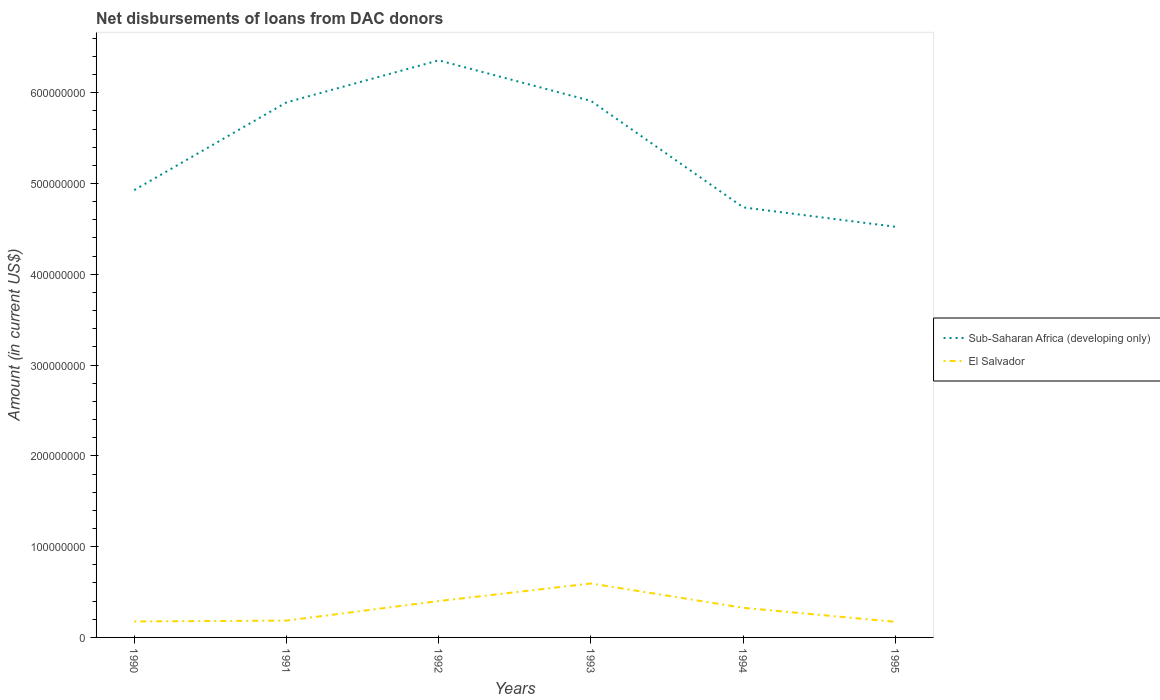How many different coloured lines are there?
Keep it short and to the point. 2. Across all years, what is the maximum amount of loans disbursed in Sub-Saharan Africa (developing only)?
Ensure brevity in your answer.  4.52e+08. In which year was the amount of loans disbursed in El Salvador maximum?
Your answer should be very brief. 1995. What is the total amount of loans disbursed in Sub-Saharan Africa (developing only) in the graph?
Give a very brief answer. -1.43e+08. What is the difference between the highest and the second highest amount of loans disbursed in Sub-Saharan Africa (developing only)?
Give a very brief answer. 1.83e+08. Is the amount of loans disbursed in El Salvador strictly greater than the amount of loans disbursed in Sub-Saharan Africa (developing only) over the years?
Make the answer very short. Yes. How many lines are there?
Provide a succinct answer. 2. How many years are there in the graph?
Your answer should be compact. 6. Are the values on the major ticks of Y-axis written in scientific E-notation?
Keep it short and to the point. No. Does the graph contain grids?
Keep it short and to the point. No. Where does the legend appear in the graph?
Make the answer very short. Center right. How many legend labels are there?
Offer a very short reply. 2. How are the legend labels stacked?
Provide a short and direct response. Vertical. What is the title of the graph?
Offer a terse response. Net disbursements of loans from DAC donors. Does "Indonesia" appear as one of the legend labels in the graph?
Your answer should be very brief. No. What is the label or title of the X-axis?
Give a very brief answer. Years. What is the Amount (in current US$) of Sub-Saharan Africa (developing only) in 1990?
Provide a short and direct response. 4.93e+08. What is the Amount (in current US$) of El Salvador in 1990?
Give a very brief answer. 1.76e+07. What is the Amount (in current US$) of Sub-Saharan Africa (developing only) in 1991?
Your answer should be very brief. 5.89e+08. What is the Amount (in current US$) of El Salvador in 1991?
Give a very brief answer. 1.85e+07. What is the Amount (in current US$) of Sub-Saharan Africa (developing only) in 1992?
Keep it short and to the point. 6.36e+08. What is the Amount (in current US$) in El Salvador in 1992?
Your response must be concise. 4.01e+07. What is the Amount (in current US$) of Sub-Saharan Africa (developing only) in 1993?
Offer a very short reply. 5.91e+08. What is the Amount (in current US$) of El Salvador in 1993?
Keep it short and to the point. 5.94e+07. What is the Amount (in current US$) in Sub-Saharan Africa (developing only) in 1994?
Make the answer very short. 4.74e+08. What is the Amount (in current US$) of El Salvador in 1994?
Offer a very short reply. 3.26e+07. What is the Amount (in current US$) in Sub-Saharan Africa (developing only) in 1995?
Your response must be concise. 4.52e+08. What is the Amount (in current US$) in El Salvador in 1995?
Provide a short and direct response. 1.72e+07. Across all years, what is the maximum Amount (in current US$) of Sub-Saharan Africa (developing only)?
Ensure brevity in your answer.  6.36e+08. Across all years, what is the maximum Amount (in current US$) in El Salvador?
Offer a very short reply. 5.94e+07. Across all years, what is the minimum Amount (in current US$) in Sub-Saharan Africa (developing only)?
Your answer should be very brief. 4.52e+08. Across all years, what is the minimum Amount (in current US$) of El Salvador?
Provide a succinct answer. 1.72e+07. What is the total Amount (in current US$) of Sub-Saharan Africa (developing only) in the graph?
Ensure brevity in your answer.  3.23e+09. What is the total Amount (in current US$) of El Salvador in the graph?
Give a very brief answer. 1.85e+08. What is the difference between the Amount (in current US$) in Sub-Saharan Africa (developing only) in 1990 and that in 1991?
Offer a terse response. -9.66e+07. What is the difference between the Amount (in current US$) of El Salvador in 1990 and that in 1991?
Offer a terse response. -9.30e+05. What is the difference between the Amount (in current US$) in Sub-Saharan Africa (developing only) in 1990 and that in 1992?
Give a very brief answer. -1.43e+08. What is the difference between the Amount (in current US$) in El Salvador in 1990 and that in 1992?
Keep it short and to the point. -2.25e+07. What is the difference between the Amount (in current US$) of Sub-Saharan Africa (developing only) in 1990 and that in 1993?
Your answer should be compact. -9.82e+07. What is the difference between the Amount (in current US$) of El Salvador in 1990 and that in 1993?
Your response must be concise. -4.18e+07. What is the difference between the Amount (in current US$) of Sub-Saharan Africa (developing only) in 1990 and that in 1994?
Your answer should be very brief. 1.90e+07. What is the difference between the Amount (in current US$) of El Salvador in 1990 and that in 1994?
Provide a short and direct response. -1.50e+07. What is the difference between the Amount (in current US$) of Sub-Saharan Africa (developing only) in 1990 and that in 1995?
Your response must be concise. 4.04e+07. What is the difference between the Amount (in current US$) in El Salvador in 1990 and that in 1995?
Keep it short and to the point. 4.42e+05. What is the difference between the Amount (in current US$) of Sub-Saharan Africa (developing only) in 1991 and that in 1992?
Keep it short and to the point. -4.63e+07. What is the difference between the Amount (in current US$) in El Salvador in 1991 and that in 1992?
Your answer should be very brief. -2.15e+07. What is the difference between the Amount (in current US$) of Sub-Saharan Africa (developing only) in 1991 and that in 1993?
Offer a very short reply. -1.59e+06. What is the difference between the Amount (in current US$) in El Salvador in 1991 and that in 1993?
Give a very brief answer. -4.09e+07. What is the difference between the Amount (in current US$) of Sub-Saharan Africa (developing only) in 1991 and that in 1994?
Provide a succinct answer. 1.16e+08. What is the difference between the Amount (in current US$) of El Salvador in 1991 and that in 1994?
Provide a succinct answer. -1.41e+07. What is the difference between the Amount (in current US$) in Sub-Saharan Africa (developing only) in 1991 and that in 1995?
Your answer should be very brief. 1.37e+08. What is the difference between the Amount (in current US$) in El Salvador in 1991 and that in 1995?
Your answer should be very brief. 1.37e+06. What is the difference between the Amount (in current US$) in Sub-Saharan Africa (developing only) in 1992 and that in 1993?
Your response must be concise. 4.47e+07. What is the difference between the Amount (in current US$) in El Salvador in 1992 and that in 1993?
Give a very brief answer. -1.94e+07. What is the difference between the Amount (in current US$) of Sub-Saharan Africa (developing only) in 1992 and that in 1994?
Your response must be concise. 1.62e+08. What is the difference between the Amount (in current US$) in El Salvador in 1992 and that in 1994?
Provide a succinct answer. 7.44e+06. What is the difference between the Amount (in current US$) in Sub-Saharan Africa (developing only) in 1992 and that in 1995?
Provide a succinct answer. 1.83e+08. What is the difference between the Amount (in current US$) of El Salvador in 1992 and that in 1995?
Offer a very short reply. 2.29e+07. What is the difference between the Amount (in current US$) of Sub-Saharan Africa (developing only) in 1993 and that in 1994?
Offer a terse response. 1.17e+08. What is the difference between the Amount (in current US$) of El Salvador in 1993 and that in 1994?
Ensure brevity in your answer.  2.68e+07. What is the difference between the Amount (in current US$) in Sub-Saharan Africa (developing only) in 1993 and that in 1995?
Your answer should be very brief. 1.39e+08. What is the difference between the Amount (in current US$) in El Salvador in 1993 and that in 1995?
Keep it short and to the point. 4.23e+07. What is the difference between the Amount (in current US$) of Sub-Saharan Africa (developing only) in 1994 and that in 1995?
Ensure brevity in your answer.  2.14e+07. What is the difference between the Amount (in current US$) of El Salvador in 1994 and that in 1995?
Provide a short and direct response. 1.55e+07. What is the difference between the Amount (in current US$) in Sub-Saharan Africa (developing only) in 1990 and the Amount (in current US$) in El Salvador in 1991?
Give a very brief answer. 4.74e+08. What is the difference between the Amount (in current US$) in Sub-Saharan Africa (developing only) in 1990 and the Amount (in current US$) in El Salvador in 1992?
Keep it short and to the point. 4.53e+08. What is the difference between the Amount (in current US$) of Sub-Saharan Africa (developing only) in 1990 and the Amount (in current US$) of El Salvador in 1993?
Provide a short and direct response. 4.33e+08. What is the difference between the Amount (in current US$) in Sub-Saharan Africa (developing only) in 1990 and the Amount (in current US$) in El Salvador in 1994?
Ensure brevity in your answer.  4.60e+08. What is the difference between the Amount (in current US$) of Sub-Saharan Africa (developing only) in 1990 and the Amount (in current US$) of El Salvador in 1995?
Offer a terse response. 4.76e+08. What is the difference between the Amount (in current US$) in Sub-Saharan Africa (developing only) in 1991 and the Amount (in current US$) in El Salvador in 1992?
Make the answer very short. 5.49e+08. What is the difference between the Amount (in current US$) of Sub-Saharan Africa (developing only) in 1991 and the Amount (in current US$) of El Salvador in 1993?
Your answer should be very brief. 5.30e+08. What is the difference between the Amount (in current US$) in Sub-Saharan Africa (developing only) in 1991 and the Amount (in current US$) in El Salvador in 1994?
Your answer should be compact. 5.57e+08. What is the difference between the Amount (in current US$) of Sub-Saharan Africa (developing only) in 1991 and the Amount (in current US$) of El Salvador in 1995?
Make the answer very short. 5.72e+08. What is the difference between the Amount (in current US$) in Sub-Saharan Africa (developing only) in 1992 and the Amount (in current US$) in El Salvador in 1993?
Keep it short and to the point. 5.76e+08. What is the difference between the Amount (in current US$) of Sub-Saharan Africa (developing only) in 1992 and the Amount (in current US$) of El Salvador in 1994?
Give a very brief answer. 6.03e+08. What is the difference between the Amount (in current US$) in Sub-Saharan Africa (developing only) in 1992 and the Amount (in current US$) in El Salvador in 1995?
Offer a terse response. 6.19e+08. What is the difference between the Amount (in current US$) of Sub-Saharan Africa (developing only) in 1993 and the Amount (in current US$) of El Salvador in 1994?
Make the answer very short. 5.58e+08. What is the difference between the Amount (in current US$) in Sub-Saharan Africa (developing only) in 1993 and the Amount (in current US$) in El Salvador in 1995?
Offer a terse response. 5.74e+08. What is the difference between the Amount (in current US$) of Sub-Saharan Africa (developing only) in 1994 and the Amount (in current US$) of El Salvador in 1995?
Provide a short and direct response. 4.57e+08. What is the average Amount (in current US$) in Sub-Saharan Africa (developing only) per year?
Your response must be concise. 5.39e+08. What is the average Amount (in current US$) of El Salvador per year?
Offer a terse response. 3.09e+07. In the year 1990, what is the difference between the Amount (in current US$) of Sub-Saharan Africa (developing only) and Amount (in current US$) of El Salvador?
Give a very brief answer. 4.75e+08. In the year 1991, what is the difference between the Amount (in current US$) in Sub-Saharan Africa (developing only) and Amount (in current US$) in El Salvador?
Offer a very short reply. 5.71e+08. In the year 1992, what is the difference between the Amount (in current US$) of Sub-Saharan Africa (developing only) and Amount (in current US$) of El Salvador?
Your answer should be compact. 5.96e+08. In the year 1993, what is the difference between the Amount (in current US$) in Sub-Saharan Africa (developing only) and Amount (in current US$) in El Salvador?
Provide a short and direct response. 5.32e+08. In the year 1994, what is the difference between the Amount (in current US$) of Sub-Saharan Africa (developing only) and Amount (in current US$) of El Salvador?
Offer a terse response. 4.41e+08. In the year 1995, what is the difference between the Amount (in current US$) of Sub-Saharan Africa (developing only) and Amount (in current US$) of El Salvador?
Offer a terse response. 4.35e+08. What is the ratio of the Amount (in current US$) in Sub-Saharan Africa (developing only) in 1990 to that in 1991?
Your answer should be very brief. 0.84. What is the ratio of the Amount (in current US$) of El Salvador in 1990 to that in 1991?
Ensure brevity in your answer.  0.95. What is the ratio of the Amount (in current US$) in Sub-Saharan Africa (developing only) in 1990 to that in 1992?
Offer a terse response. 0.78. What is the ratio of the Amount (in current US$) of El Salvador in 1990 to that in 1992?
Offer a very short reply. 0.44. What is the ratio of the Amount (in current US$) of Sub-Saharan Africa (developing only) in 1990 to that in 1993?
Your response must be concise. 0.83. What is the ratio of the Amount (in current US$) of El Salvador in 1990 to that in 1993?
Keep it short and to the point. 0.3. What is the ratio of the Amount (in current US$) in Sub-Saharan Africa (developing only) in 1990 to that in 1994?
Provide a short and direct response. 1.04. What is the ratio of the Amount (in current US$) in El Salvador in 1990 to that in 1994?
Give a very brief answer. 0.54. What is the ratio of the Amount (in current US$) of Sub-Saharan Africa (developing only) in 1990 to that in 1995?
Offer a terse response. 1.09. What is the ratio of the Amount (in current US$) of El Salvador in 1990 to that in 1995?
Make the answer very short. 1.03. What is the ratio of the Amount (in current US$) in Sub-Saharan Africa (developing only) in 1991 to that in 1992?
Provide a succinct answer. 0.93. What is the ratio of the Amount (in current US$) in El Salvador in 1991 to that in 1992?
Your answer should be compact. 0.46. What is the ratio of the Amount (in current US$) of El Salvador in 1991 to that in 1993?
Offer a very short reply. 0.31. What is the ratio of the Amount (in current US$) in Sub-Saharan Africa (developing only) in 1991 to that in 1994?
Ensure brevity in your answer.  1.24. What is the ratio of the Amount (in current US$) of El Salvador in 1991 to that in 1994?
Give a very brief answer. 0.57. What is the ratio of the Amount (in current US$) of Sub-Saharan Africa (developing only) in 1991 to that in 1995?
Ensure brevity in your answer.  1.3. What is the ratio of the Amount (in current US$) in El Salvador in 1991 to that in 1995?
Provide a short and direct response. 1.08. What is the ratio of the Amount (in current US$) of Sub-Saharan Africa (developing only) in 1992 to that in 1993?
Ensure brevity in your answer.  1.08. What is the ratio of the Amount (in current US$) of El Salvador in 1992 to that in 1993?
Your response must be concise. 0.67. What is the ratio of the Amount (in current US$) in Sub-Saharan Africa (developing only) in 1992 to that in 1994?
Ensure brevity in your answer.  1.34. What is the ratio of the Amount (in current US$) of El Salvador in 1992 to that in 1994?
Your response must be concise. 1.23. What is the ratio of the Amount (in current US$) of Sub-Saharan Africa (developing only) in 1992 to that in 1995?
Provide a succinct answer. 1.41. What is the ratio of the Amount (in current US$) in El Salvador in 1992 to that in 1995?
Make the answer very short. 2.34. What is the ratio of the Amount (in current US$) of Sub-Saharan Africa (developing only) in 1993 to that in 1994?
Offer a terse response. 1.25. What is the ratio of the Amount (in current US$) in El Salvador in 1993 to that in 1994?
Offer a terse response. 1.82. What is the ratio of the Amount (in current US$) in Sub-Saharan Africa (developing only) in 1993 to that in 1995?
Provide a short and direct response. 1.31. What is the ratio of the Amount (in current US$) in El Salvador in 1993 to that in 1995?
Your response must be concise. 3.47. What is the ratio of the Amount (in current US$) in Sub-Saharan Africa (developing only) in 1994 to that in 1995?
Provide a short and direct response. 1.05. What is the ratio of the Amount (in current US$) in El Salvador in 1994 to that in 1995?
Provide a succinct answer. 1.9. What is the difference between the highest and the second highest Amount (in current US$) of Sub-Saharan Africa (developing only)?
Your response must be concise. 4.47e+07. What is the difference between the highest and the second highest Amount (in current US$) in El Salvador?
Your response must be concise. 1.94e+07. What is the difference between the highest and the lowest Amount (in current US$) in Sub-Saharan Africa (developing only)?
Give a very brief answer. 1.83e+08. What is the difference between the highest and the lowest Amount (in current US$) of El Salvador?
Your answer should be compact. 4.23e+07. 